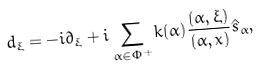Convert formula to latex. <formula><loc_0><loc_0><loc_500><loc_500>d _ { \xi } = - i \partial _ { \xi } + i \sum _ { \alpha \in \Phi ^ { + } } k ( \alpha ) \frac { ( \alpha , \xi ) } { ( \alpha , x ) } \hat { s } _ { \alpha } ,</formula> 